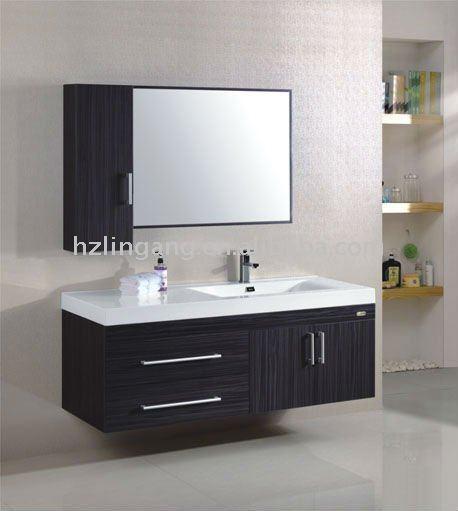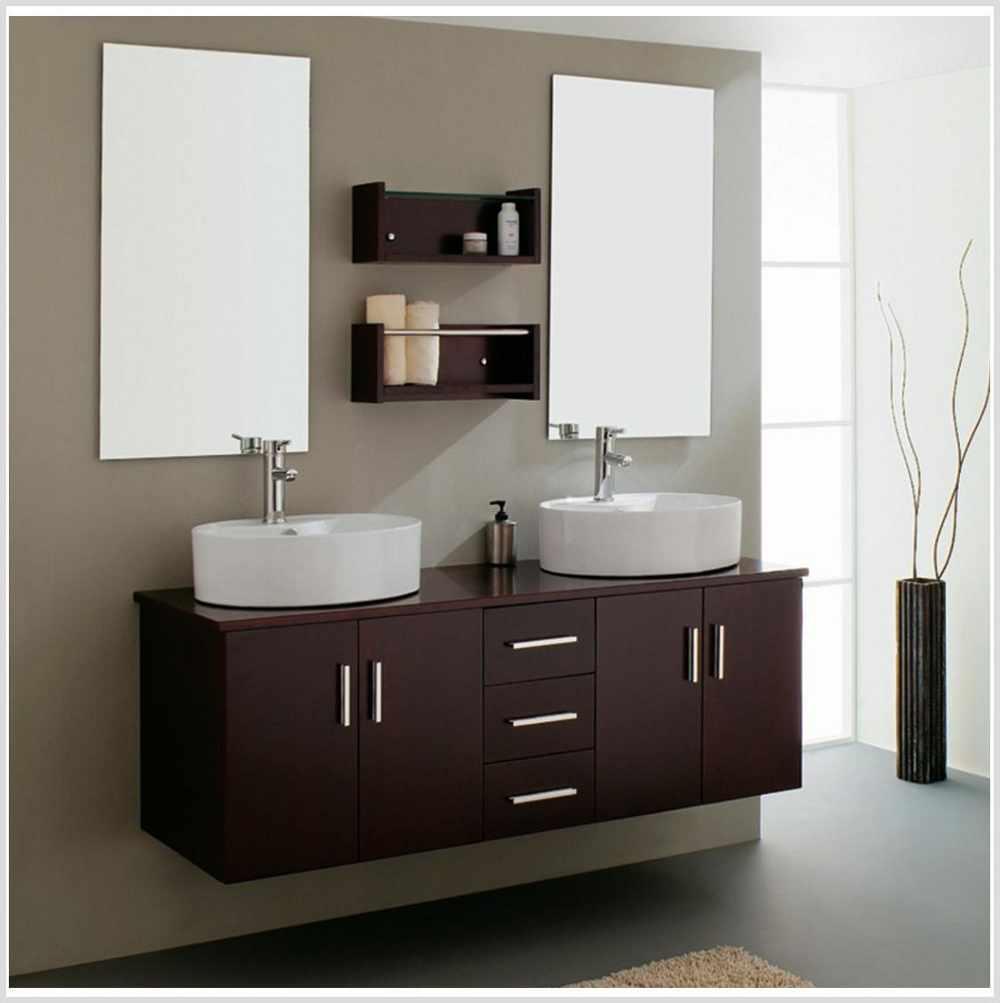The first image is the image on the left, the second image is the image on the right. Analyze the images presented: Is the assertion "Two mirrors hang over the sinks in the image on the right." valid? Answer yes or no. Yes. 